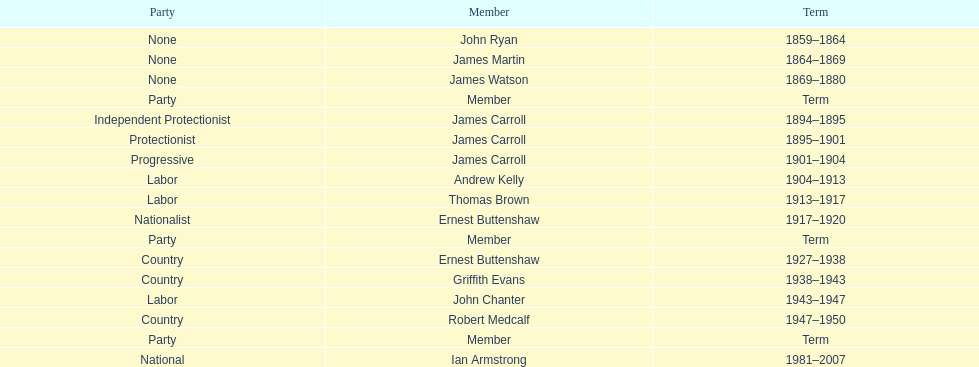Could you parse the entire table? {'header': ['Party', 'Member', 'Term'], 'rows': [['None', 'John Ryan', '1859–1864'], ['None', 'James Martin', '1864–1869'], ['None', 'James Watson', '1869–1880'], ['Party', 'Member', 'Term'], ['Independent Protectionist', 'James Carroll', '1894–1895'], ['Protectionist', 'James Carroll', '1895–1901'], ['Progressive', 'James Carroll', '1901–1904'], ['Labor', 'Andrew Kelly', '1904–1913'], ['Labor', 'Thomas Brown', '1913–1917'], ['Nationalist', 'Ernest Buttenshaw', '1917–1920'], ['Party', 'Member', 'Term'], ['Country', 'Ernest Buttenshaw', '1927–1938'], ['Country', 'Griffith Evans', '1938–1943'], ['Labor', 'John Chanter', '1943–1947'], ['Country', 'Robert Medcalf', '1947–1950'], ['Party', 'Member', 'Term'], ['National', 'Ian Armstrong', '1981–2007']]} How many years of service do the members of the second incarnation have combined? 26. 